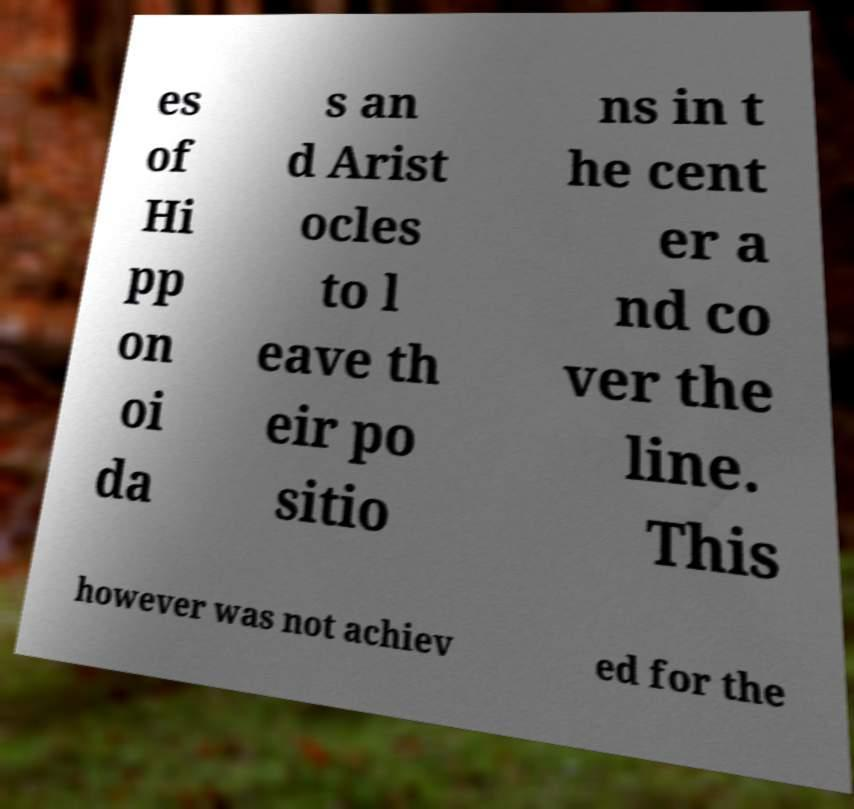There's text embedded in this image that I need extracted. Can you transcribe it verbatim? es of Hi pp on oi da s an d Arist ocles to l eave th eir po sitio ns in t he cent er a nd co ver the line. This however was not achiev ed for the 